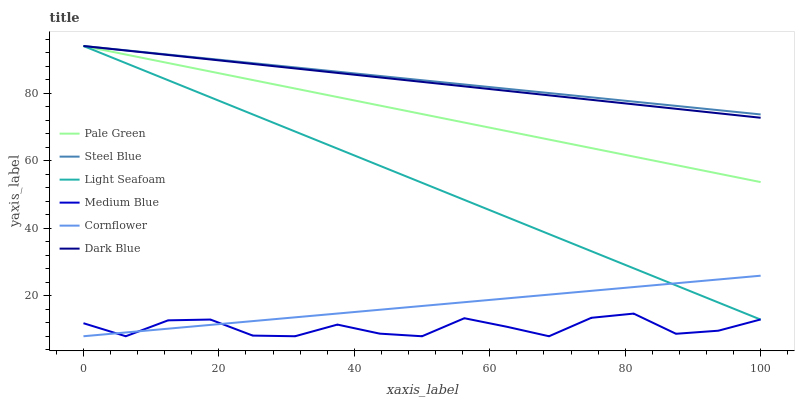Does Medium Blue have the minimum area under the curve?
Answer yes or no. Yes. Does Steel Blue have the maximum area under the curve?
Answer yes or no. Yes. Does Steel Blue have the minimum area under the curve?
Answer yes or no. No. Does Medium Blue have the maximum area under the curve?
Answer yes or no. No. Is Cornflower the smoothest?
Answer yes or no. Yes. Is Medium Blue the roughest?
Answer yes or no. Yes. Is Steel Blue the smoothest?
Answer yes or no. No. Is Steel Blue the roughest?
Answer yes or no. No. Does Cornflower have the lowest value?
Answer yes or no. Yes. Does Steel Blue have the lowest value?
Answer yes or no. No. Does Light Seafoam have the highest value?
Answer yes or no. Yes. Does Medium Blue have the highest value?
Answer yes or no. No. Is Medium Blue less than Pale Green?
Answer yes or no. Yes. Is Dark Blue greater than Medium Blue?
Answer yes or no. Yes. Does Steel Blue intersect Light Seafoam?
Answer yes or no. Yes. Is Steel Blue less than Light Seafoam?
Answer yes or no. No. Is Steel Blue greater than Light Seafoam?
Answer yes or no. No. Does Medium Blue intersect Pale Green?
Answer yes or no. No. 